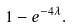<formula> <loc_0><loc_0><loc_500><loc_500>1 - e ^ { - 4 \lambda } .</formula> 